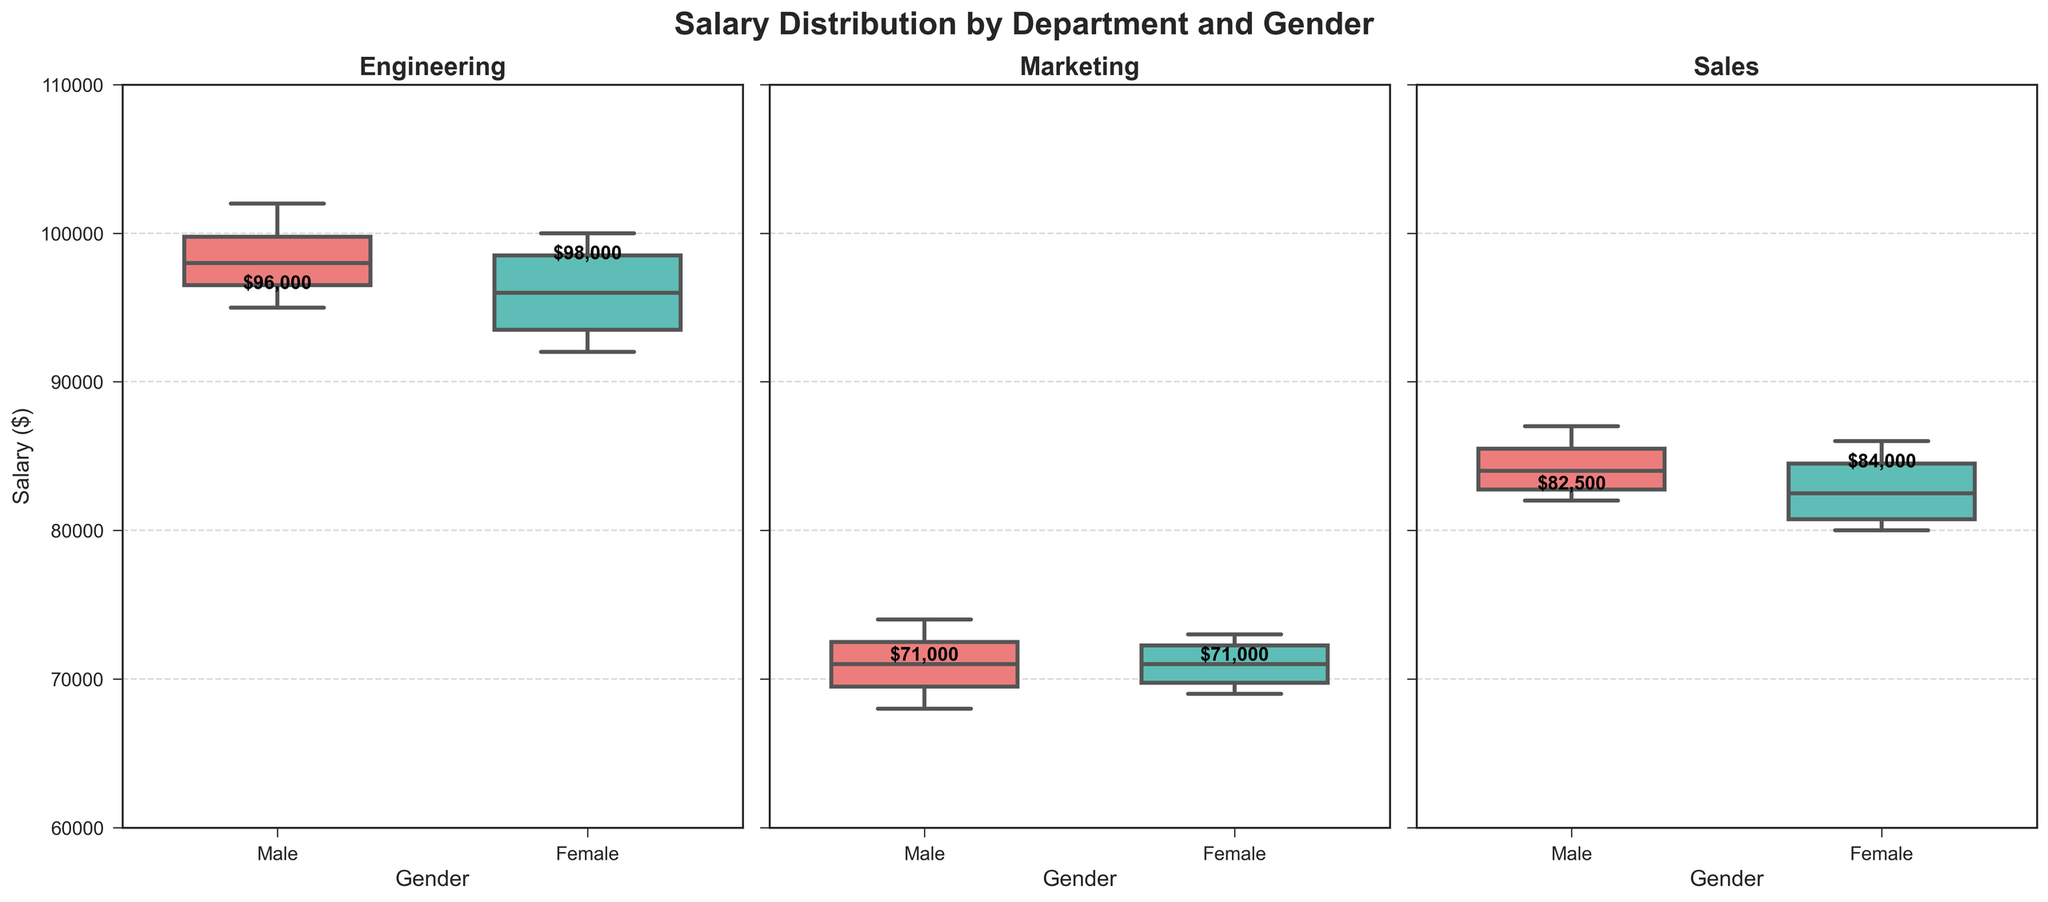What is the title of the figure? The title is displayed at the top center of the figure, which indicates the overall subject of the charts. The title is "Salary Distribution by Department and Gender".
Answer: Salary Distribution by Department and Gender Which department has the highest median salary for males? By examining the median values marked on the boxes for males across the three departments, the department with the highest median is Engineering, with a median salary of $98,500.
Answer: Engineering What is the median salary for females in the Sales department? The median salary for females in each department is typically marked inside the box plot. For Sales, this value reads as $82,500.
Answer: 82,500 How do the median salaries of males and females compare in the Marketing department? To find this, we look at the median salary markings in the Marketing box plot. Males have a median salary of $71,000 while females have a median of $71,000, implying they are equal.
Answer: Equal Which gender shows a higher maximum salary in the Engineering department? By observing the top whisker (maximum value) in the Engineering department’s box plots, males have the highest maximum salary, which is $102,000, versus females' maximum of $100,000.
Answer: Male Which department has the largest range of salaries for females? The range of salaries is given by the difference between the maximum and minimum values (whiskers). The highest range for females is in Engineering (max $100,000 - min $92,000 = $8,000).
Answer: Engineering What is the interquartile range (IQR) for male salaries in the Sales department? The IQR is the difference between the first quartile (Q1) and the third quartile (Q3). From the plot, Q3 is around $87,500 and Q1 is around $82,000, leading to an IQR of $5,500.
Answer: $5,500 Compare the salary distributions for males and females within the Engineering department. The box plot for females shows a slightly lower median and a narrower interquartile range compared to males. The whiskers for males also extend higher, indicating larger maximum values.
Answer: Males have wider distribution and higher maximum values Are the salary distributions for males and females more balanced in any specific department? Distribution balance can be observed by comparing median values and the spread/whiskers. In the Marketing department, both genders have the same median salary ($71,000), indicating a balanced distribution.
Answer: Marketing Which department shows the largest disparity between male and female salaries? Disparity can be measured by the gap between median salaries in each department. Engineering shows the largest gap, with males having a median salary approximately $2,500 higher than females.
Answer: Engineering 